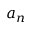<formula> <loc_0><loc_0><loc_500><loc_500>a _ { n }</formula> 